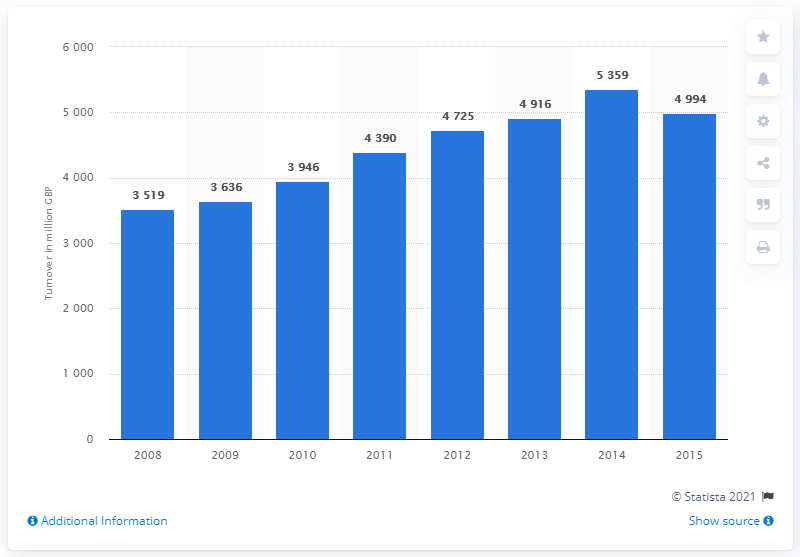Outline some significant characteristics in this image. In 2015, the total retail sales of pharmaceutical products reached 49,940 units. 